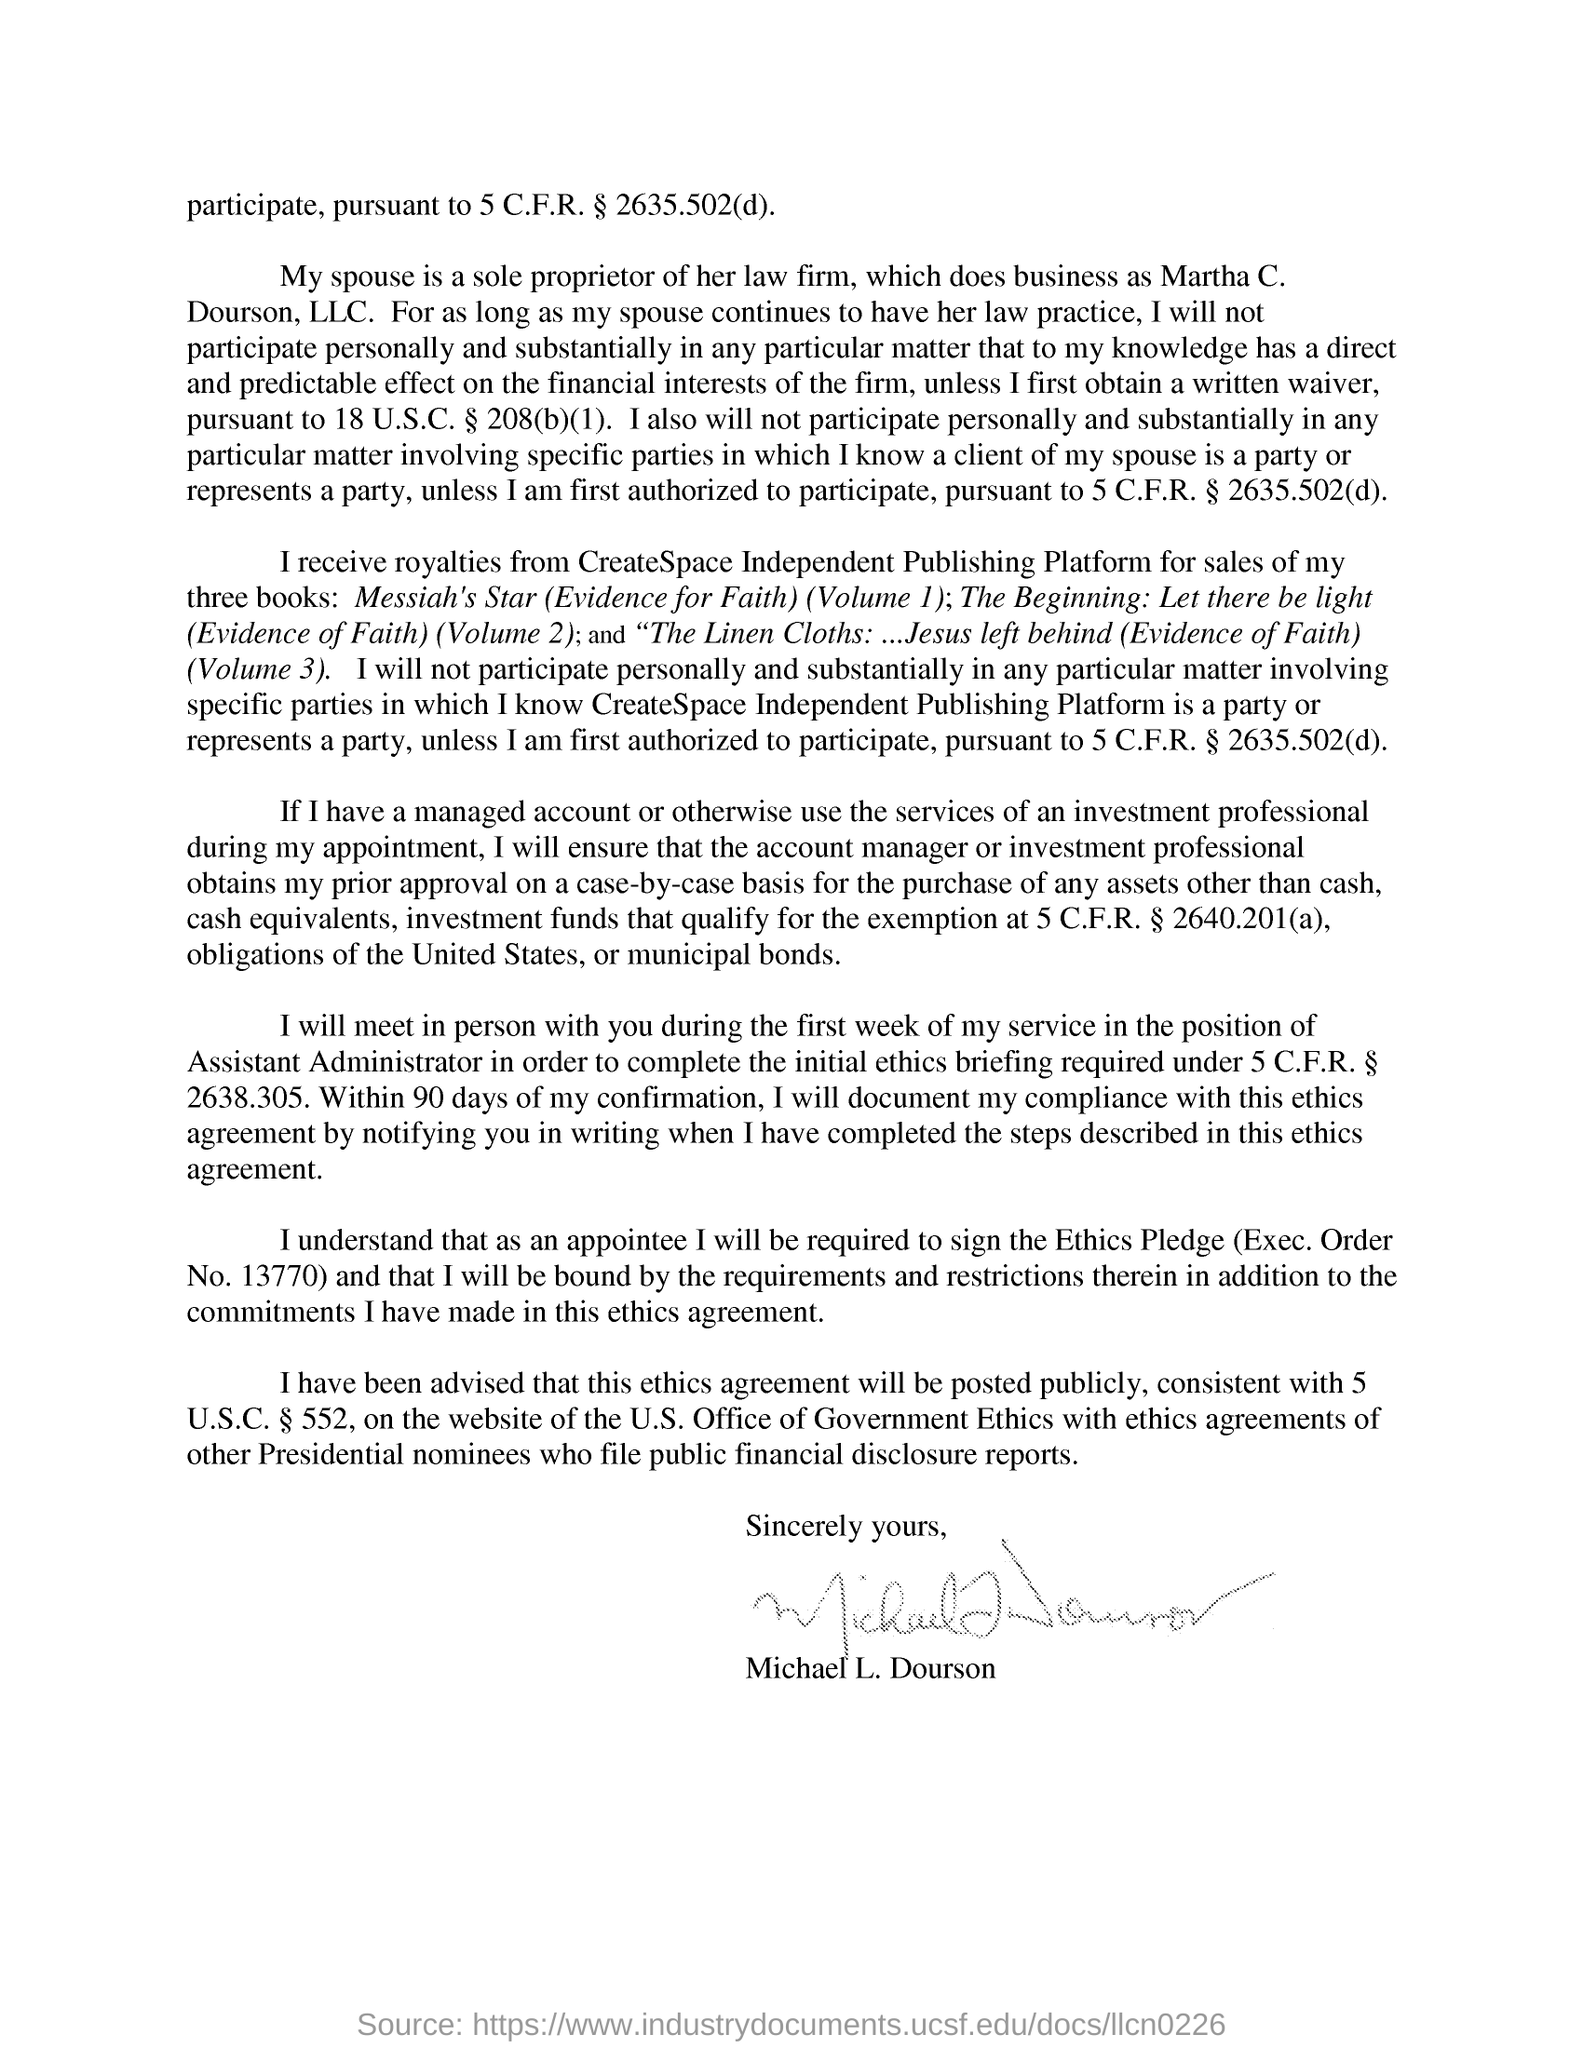By whom is this ethics agreement written?
Ensure brevity in your answer.  Michael L. Dourson. From which Publishing Platform did the author receive royalties for sales of his three books?
Keep it short and to the point. CreateSpace Independent Publishing Platform. The authors wife is a sole proprietor of which firm?
Your answer should be very brief. Law firm. Name the first book written by the author among the three?
Keep it short and to the point. Messiah's Star (Evidence for Faith) (Volume 1). 